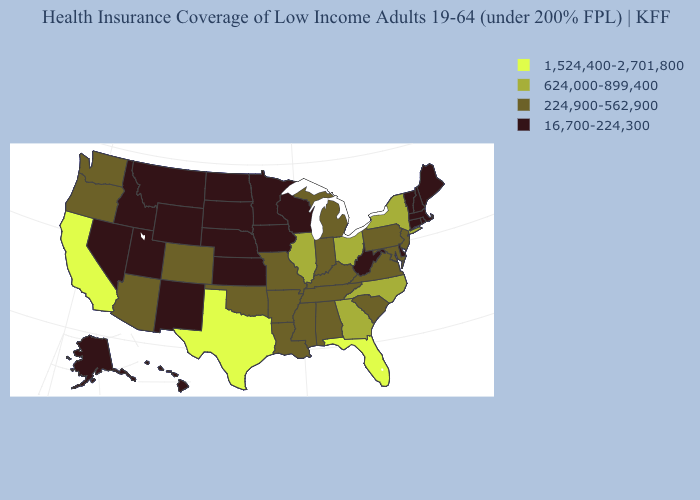What is the value of Washington?
Be succinct. 224,900-562,900. Name the states that have a value in the range 624,000-899,400?
Answer briefly. Georgia, Illinois, New York, North Carolina, Ohio. Does Tennessee have a higher value than Rhode Island?
Give a very brief answer. Yes. What is the value of Alaska?
Quick response, please. 16,700-224,300. What is the value of Tennessee?
Answer briefly. 224,900-562,900. What is the value of North Dakota?
Keep it brief. 16,700-224,300. Which states have the highest value in the USA?
Answer briefly. California, Florida, Texas. Which states have the lowest value in the West?
Short answer required. Alaska, Hawaii, Idaho, Montana, Nevada, New Mexico, Utah, Wyoming. What is the highest value in states that border Indiana?
Concise answer only. 624,000-899,400. Does Florida have the highest value in the USA?
Concise answer only. Yes. Does Kansas have a higher value than Nevada?
Answer briefly. No. What is the value of New York?
Answer briefly. 624,000-899,400. Does Texas have the highest value in the South?
Keep it brief. Yes. What is the highest value in states that border West Virginia?
Short answer required. 624,000-899,400. Does New Hampshire have a higher value than West Virginia?
Write a very short answer. No. 